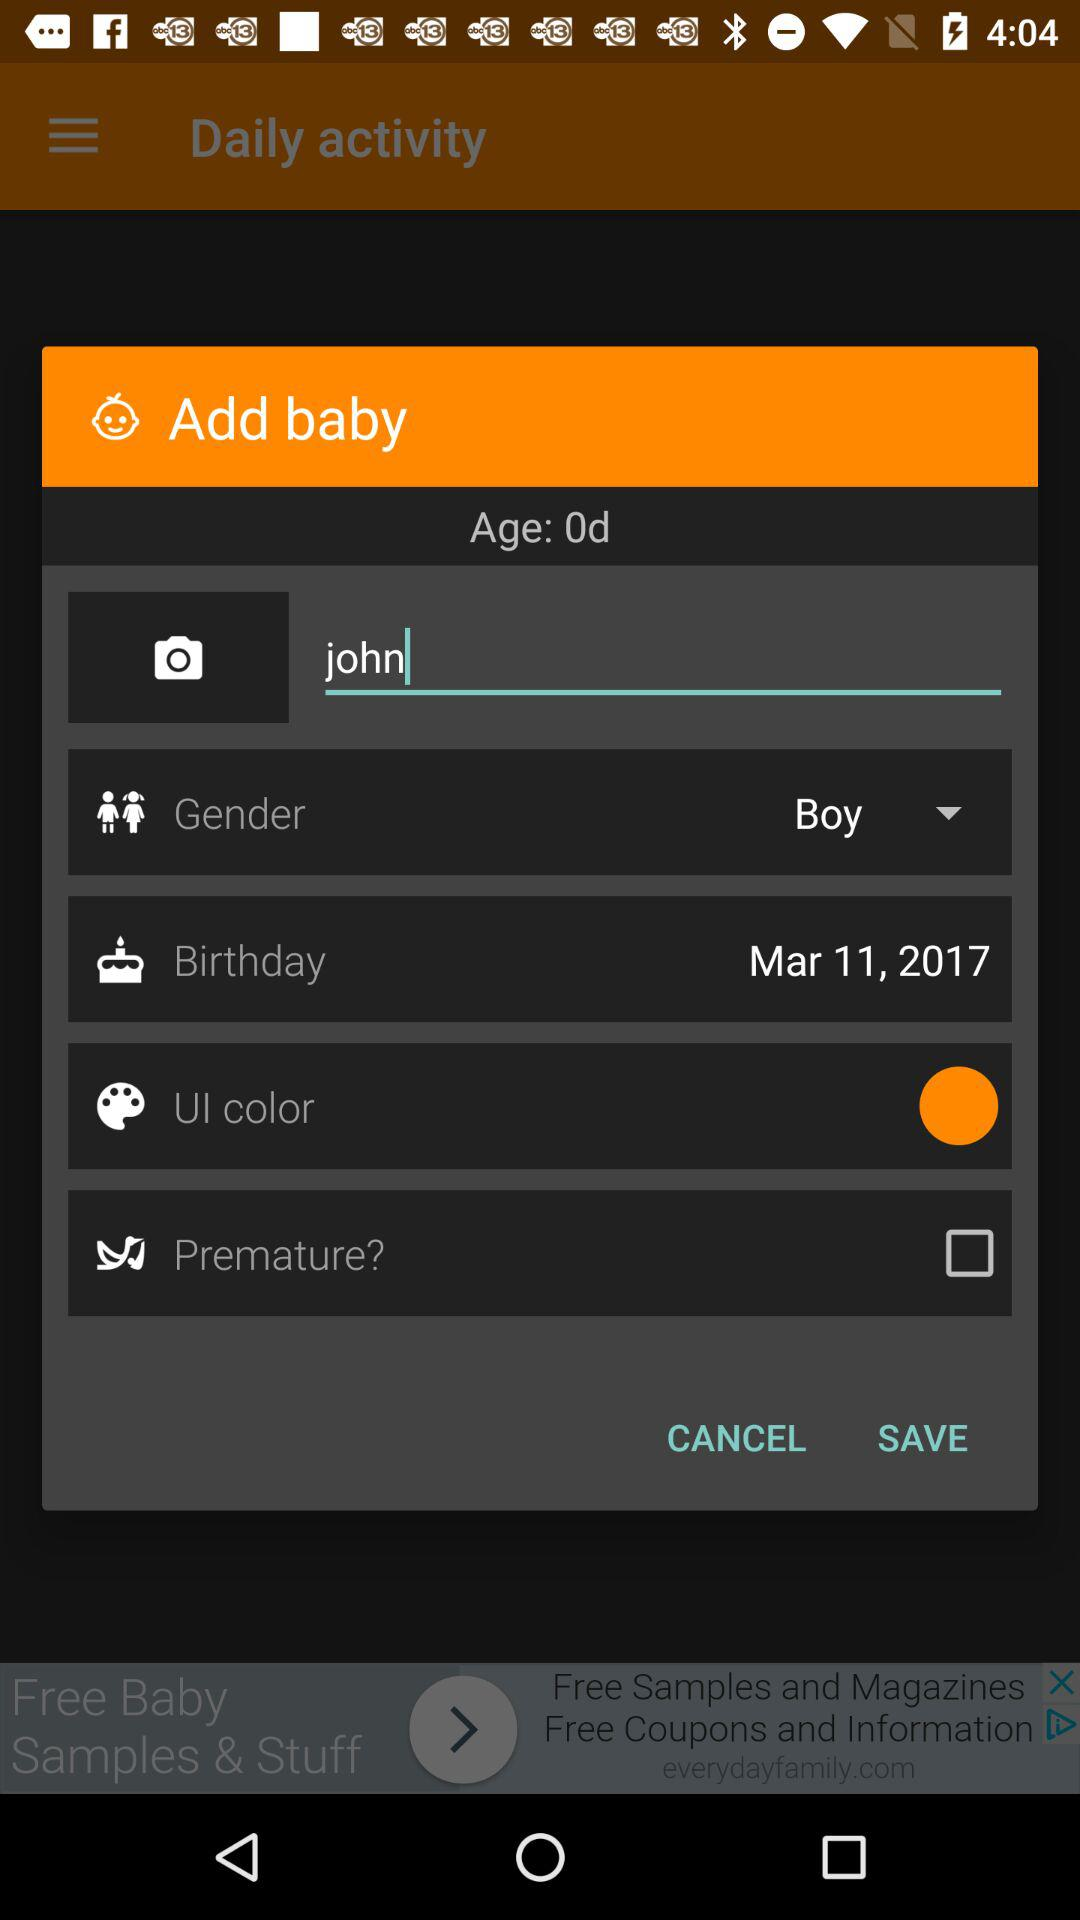What is the name of the baby? The name of the baby is John. 